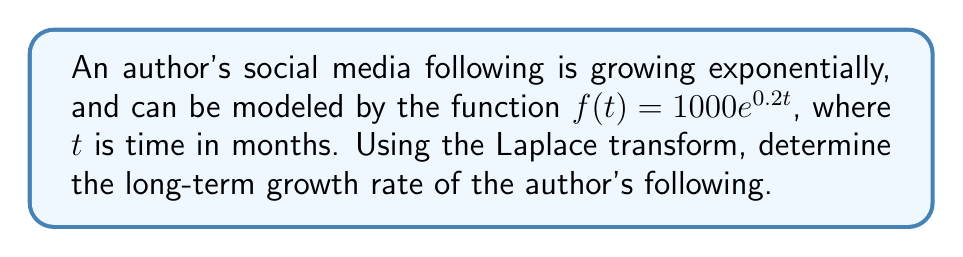Solve this math problem. To solve this problem, we'll follow these steps:

1) First, recall the Laplace transform of an exponential function:
   $\mathcal{L}\{e^{at}\} = \frac{1}{s-a}$, for $s > a$

2) The given function is $f(t) = 1000e^{0.2t}$. Let's take its Laplace transform:
   
   $$\mathcal{L}\{f(t)\} = \mathcal{L}\{1000e^{0.2t}\} = 1000\mathcal{L}\{e^{0.2t}\}$$

3) Using the property from step 1:

   $$\mathcal{L}\{f(t)\} = 1000 \cdot \frac{1}{s-0.2} = \frac{1000}{s-0.2}$$

4) To find the long-term growth rate, we need to find the limit of $f(t)$ as $t$ approaches infinity. In the s-domain, this corresponds to the limit as $s$ approaches 0 (Final Value Theorem).

5) Using the Final Value Theorem:

   $$\lim_{t \to \infty} f(t) = \lim_{s \to 0} s\mathcal{L}\{f(t)\} = \lim_{s \to 0} s \cdot \frac{1000}{s-0.2}$$

6) Evaluating this limit:

   $$\lim_{s \to 0} \frac{1000s}{s-0.2} = \frac{1000 \cdot 0}{0-0.2} = \infty$$

7) This means the function grows without bound as time increases. To find the growth rate, we can look at the exponent in the original function: $0.2t$

8) The growth rate is therefore 0.2 per month, or 20% per month.
Answer: The long-term growth rate of the author's social media following is 20% per month. 